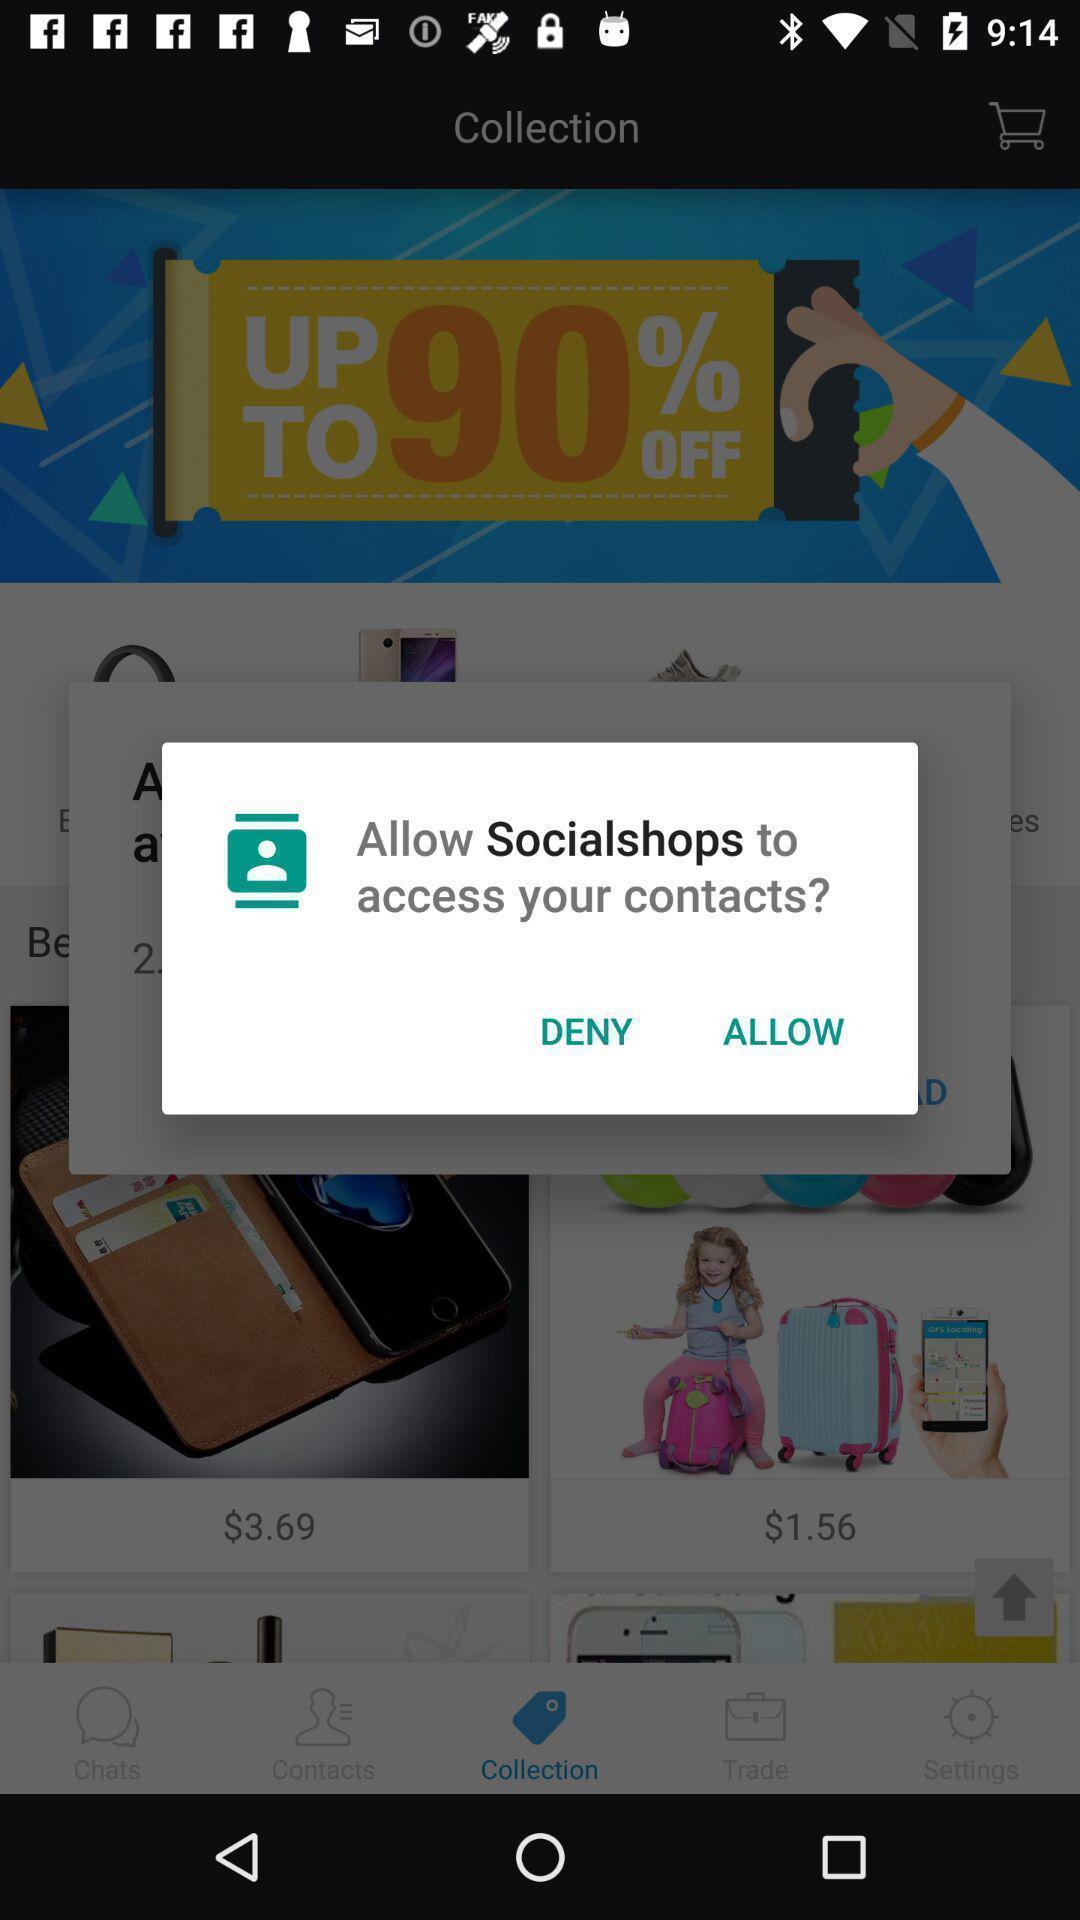Describe the content in this image. Popup page for allowing an app for access of contacts. 